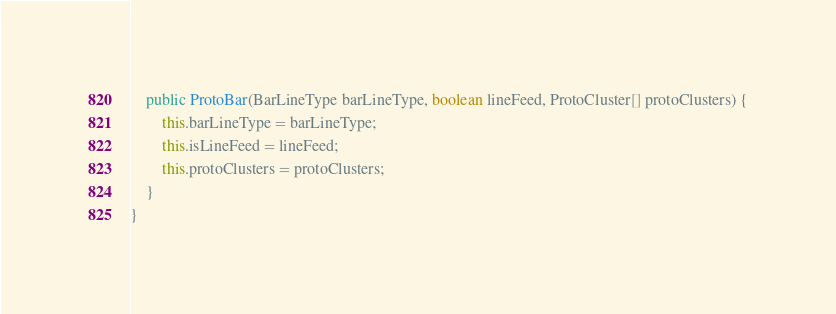Convert code to text. <code><loc_0><loc_0><loc_500><loc_500><_Java_>
	public ProtoBar(BarLineType barLineType, boolean lineFeed, ProtoCluster[] protoClusters) {
		this.barLineType = barLineType;
		this.isLineFeed = lineFeed;
		this.protoClusters = protoClusters;
	}
}</code> 